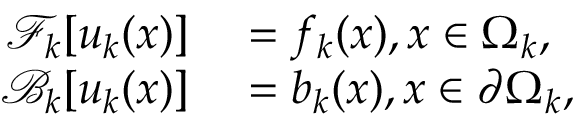Convert formula to latex. <formula><loc_0><loc_0><loc_500><loc_500>\begin{array} { r l } { \mathcal { F } _ { k } [ u _ { k } ( x ) ] } & = f _ { k } ( x ) , x \in \Omega _ { k } , } \\ { \mathcal { B } _ { k } [ u _ { k } ( x ) ] } & = b _ { k } ( x ) , x \in \partial \Omega _ { k } , } \end{array}</formula> 